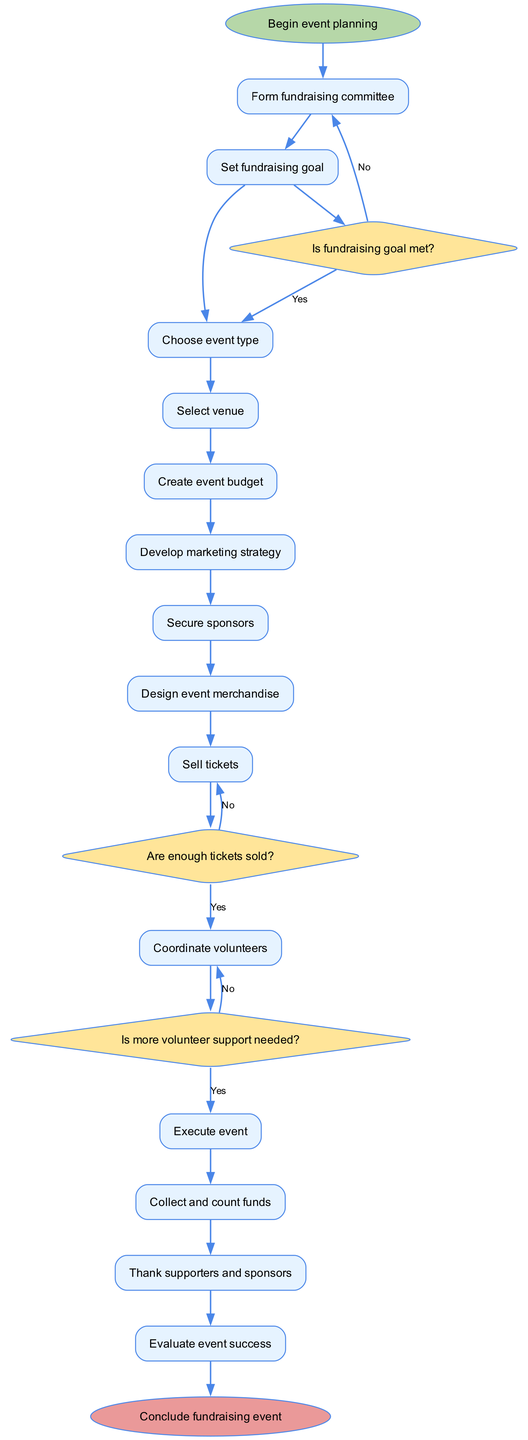What is the first step in the fundraising event planning process? The diagram indicates that the first step is "Begin event planning," which is represented at the start of the flowchart.
Answer: Begin event planning How many decisions are there in the diagram? The diagram lists three decisions, which are shown as diamonds within the flowchart.
Answer: 3 What happens if the fundraising goal is not met after setting it? According to the flowchart, if the fundraising goal is not met, the flow redirects back to the "Form fundraising committee" node.
Answer: Form fundraising committee What is the last step in the execution process? The flowchart indicates that the last step is "Evaluate event success," which connects to the end of the process.
Answer: Evaluate event success What action follows after selling tickets? After the "Sell tickets" node, the next step in the process is a decision node: "Are enough tickets sold?" This indicates the necessity of evaluating ticket sales before proceeding.
Answer: Are enough tickets sold? Is volunteer coordination necessary before executing the event? Yes, the flowchart shows that "Coordinate volunteers" must be completed before moving to the "Execute event."
Answer: Yes If enough tickets are not sold, what would be the alternate action noted? The flowchart illustrates that if not enough tickets are sold, it loops back to the "Sell tickets" node, indicating a need to continue selling.
Answer: Sell tickets Which step directly follows securing sponsors? After securing sponsors, the next action is "Design event merchandise," which continues the flow of the planning process.
Answer: Design event merchandise 